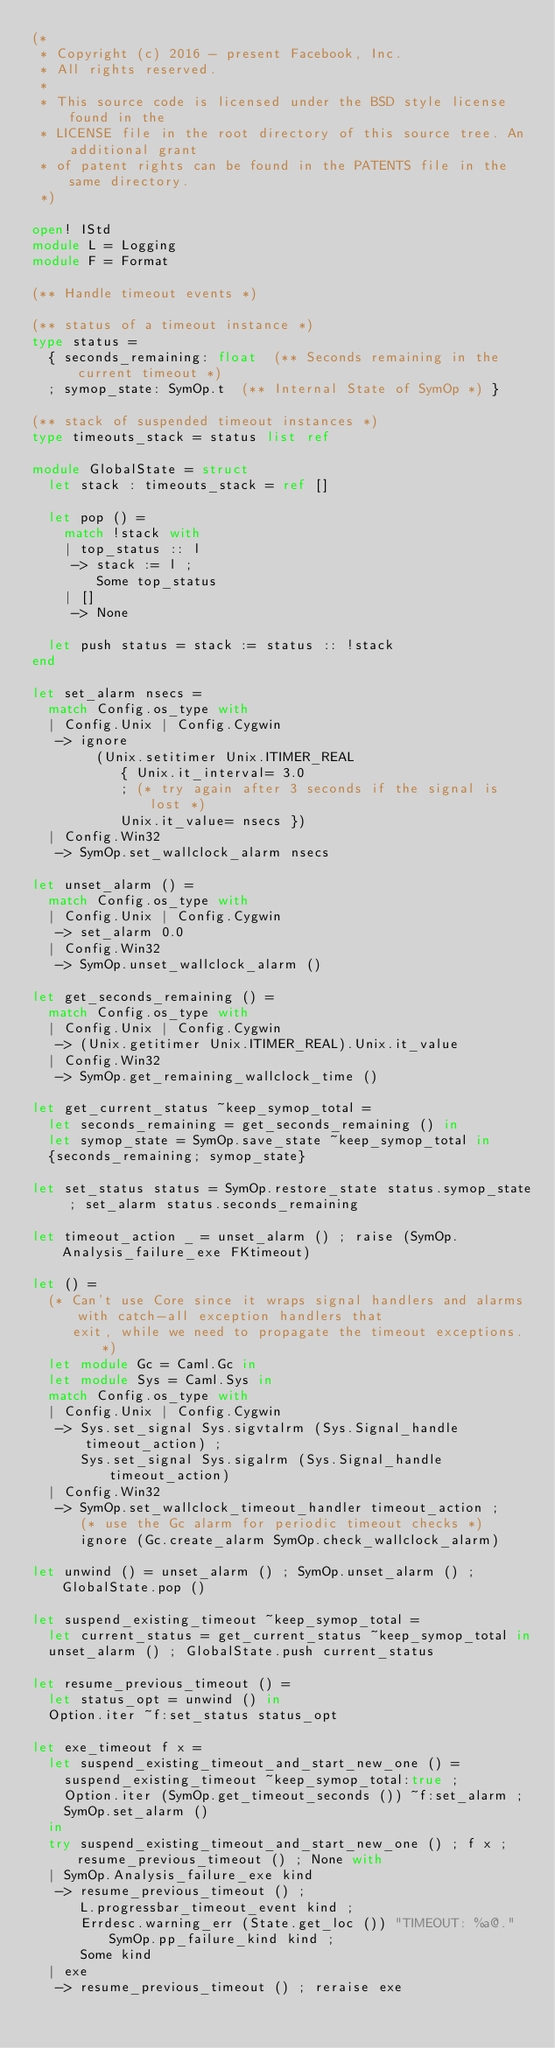Convert code to text. <code><loc_0><loc_0><loc_500><loc_500><_OCaml_>(*
 * Copyright (c) 2016 - present Facebook, Inc.
 * All rights reserved.
 *
 * This source code is licensed under the BSD style license found in the
 * LICENSE file in the root directory of this source tree. An additional grant
 * of patent rights can be found in the PATENTS file in the same directory.
 *)

open! IStd
module L = Logging
module F = Format

(** Handle timeout events *)

(** status of a timeout instance *)
type status =
  { seconds_remaining: float  (** Seconds remaining in the current timeout *)
  ; symop_state: SymOp.t  (** Internal State of SymOp *) }

(** stack of suspended timeout instances *)
type timeouts_stack = status list ref

module GlobalState = struct
  let stack : timeouts_stack = ref []

  let pop () =
    match !stack with
    | top_status :: l
     -> stack := l ;
        Some top_status
    | []
     -> None

  let push status = stack := status :: !stack
end

let set_alarm nsecs =
  match Config.os_type with
  | Config.Unix | Config.Cygwin
   -> ignore
        (Unix.setitimer Unix.ITIMER_REAL
           { Unix.it_interval= 3.0
           ; (* try again after 3 seconds if the signal is lost *)
           Unix.it_value= nsecs })
  | Config.Win32
   -> SymOp.set_wallclock_alarm nsecs

let unset_alarm () =
  match Config.os_type with
  | Config.Unix | Config.Cygwin
   -> set_alarm 0.0
  | Config.Win32
   -> SymOp.unset_wallclock_alarm ()

let get_seconds_remaining () =
  match Config.os_type with
  | Config.Unix | Config.Cygwin
   -> (Unix.getitimer Unix.ITIMER_REAL).Unix.it_value
  | Config.Win32
   -> SymOp.get_remaining_wallclock_time ()

let get_current_status ~keep_symop_total =
  let seconds_remaining = get_seconds_remaining () in
  let symop_state = SymOp.save_state ~keep_symop_total in
  {seconds_remaining; symop_state}

let set_status status = SymOp.restore_state status.symop_state ; set_alarm status.seconds_remaining

let timeout_action _ = unset_alarm () ; raise (SymOp.Analysis_failure_exe FKtimeout)

let () =
  (* Can't use Core since it wraps signal handlers and alarms with catch-all exception handlers that
     exit, while we need to propagate the timeout exceptions. *)
  let module Gc = Caml.Gc in
  let module Sys = Caml.Sys in
  match Config.os_type with
  | Config.Unix | Config.Cygwin
   -> Sys.set_signal Sys.sigvtalrm (Sys.Signal_handle timeout_action) ;
      Sys.set_signal Sys.sigalrm (Sys.Signal_handle timeout_action)
  | Config.Win32
   -> SymOp.set_wallclock_timeout_handler timeout_action ;
      (* use the Gc alarm for periodic timeout checks *)
      ignore (Gc.create_alarm SymOp.check_wallclock_alarm)

let unwind () = unset_alarm () ; SymOp.unset_alarm () ; GlobalState.pop ()

let suspend_existing_timeout ~keep_symop_total =
  let current_status = get_current_status ~keep_symop_total in
  unset_alarm () ; GlobalState.push current_status

let resume_previous_timeout () =
  let status_opt = unwind () in
  Option.iter ~f:set_status status_opt

let exe_timeout f x =
  let suspend_existing_timeout_and_start_new_one () =
    suspend_existing_timeout ~keep_symop_total:true ;
    Option.iter (SymOp.get_timeout_seconds ()) ~f:set_alarm ;
    SymOp.set_alarm ()
  in
  try suspend_existing_timeout_and_start_new_one () ; f x ; resume_previous_timeout () ; None with
  | SymOp.Analysis_failure_exe kind
   -> resume_previous_timeout () ;
      L.progressbar_timeout_event kind ;
      Errdesc.warning_err (State.get_loc ()) "TIMEOUT: %a@." SymOp.pp_failure_kind kind ;
      Some kind
  | exe
   -> resume_previous_timeout () ; reraise exe
</code> 